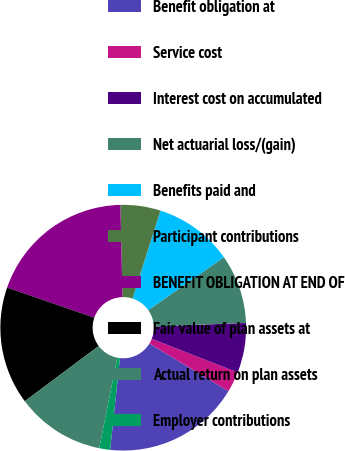<chart> <loc_0><loc_0><loc_500><loc_500><pie_chart><fcel>Benefit obligation at<fcel>Service cost<fcel>Interest cost on accumulated<fcel>Net actuarial loss/(gain)<fcel>Benefits paid and<fcel>Participant contributions<fcel>BENEFIT OBLIGATION AT END OF<fcel>Fair value of plan assets at<fcel>Actual return on plan assets<fcel>Employer contributions<nl><fcel>18.06%<fcel>2.71%<fcel>6.55%<fcel>9.1%<fcel>10.38%<fcel>5.27%<fcel>19.34%<fcel>15.5%<fcel>11.66%<fcel>1.43%<nl></chart> 